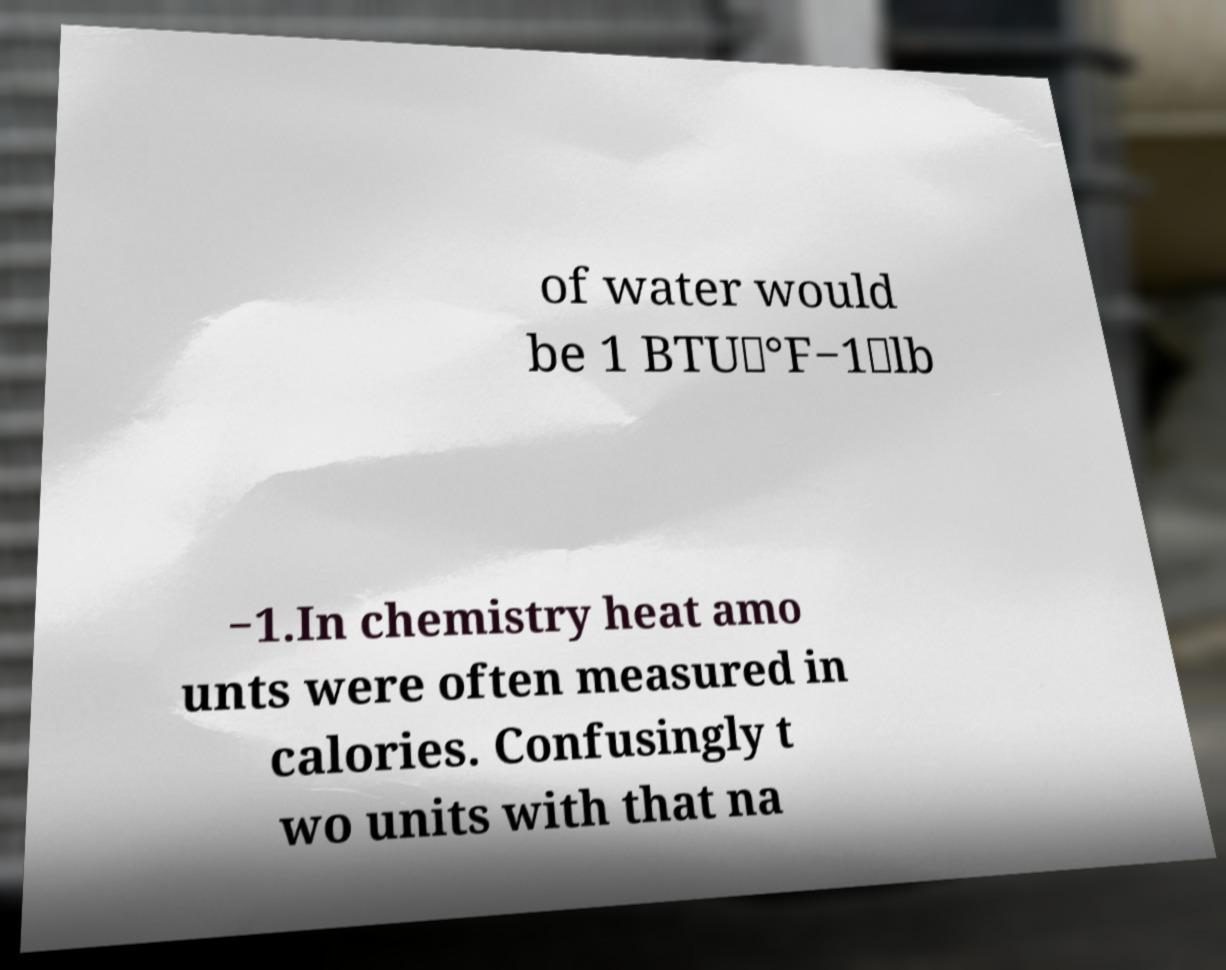I need the written content from this picture converted into text. Can you do that? of water would be 1 BTU⋅°F−1⋅lb −1.In chemistry heat amo unts were often measured in calories. Confusingly t wo units with that na 